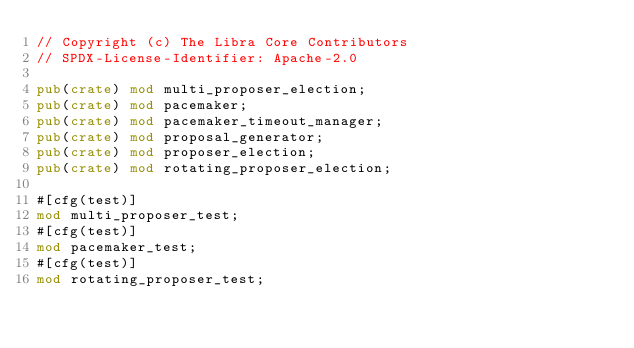Convert code to text. <code><loc_0><loc_0><loc_500><loc_500><_Rust_>// Copyright (c) The Libra Core Contributors
// SPDX-License-Identifier: Apache-2.0

pub(crate) mod multi_proposer_election;
pub(crate) mod pacemaker;
pub(crate) mod pacemaker_timeout_manager;
pub(crate) mod proposal_generator;
pub(crate) mod proposer_election;
pub(crate) mod rotating_proposer_election;

#[cfg(test)]
mod multi_proposer_test;
#[cfg(test)]
mod pacemaker_test;
#[cfg(test)]
mod rotating_proposer_test;
</code> 